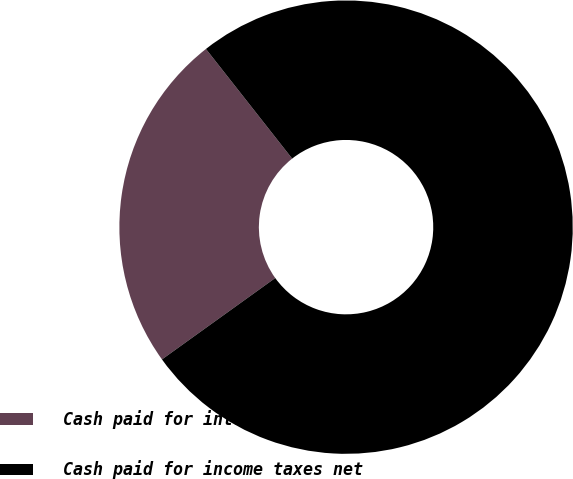<chart> <loc_0><loc_0><loc_500><loc_500><pie_chart><fcel>Cash paid for interest<fcel>Cash paid for income taxes net<nl><fcel>24.31%<fcel>75.69%<nl></chart> 